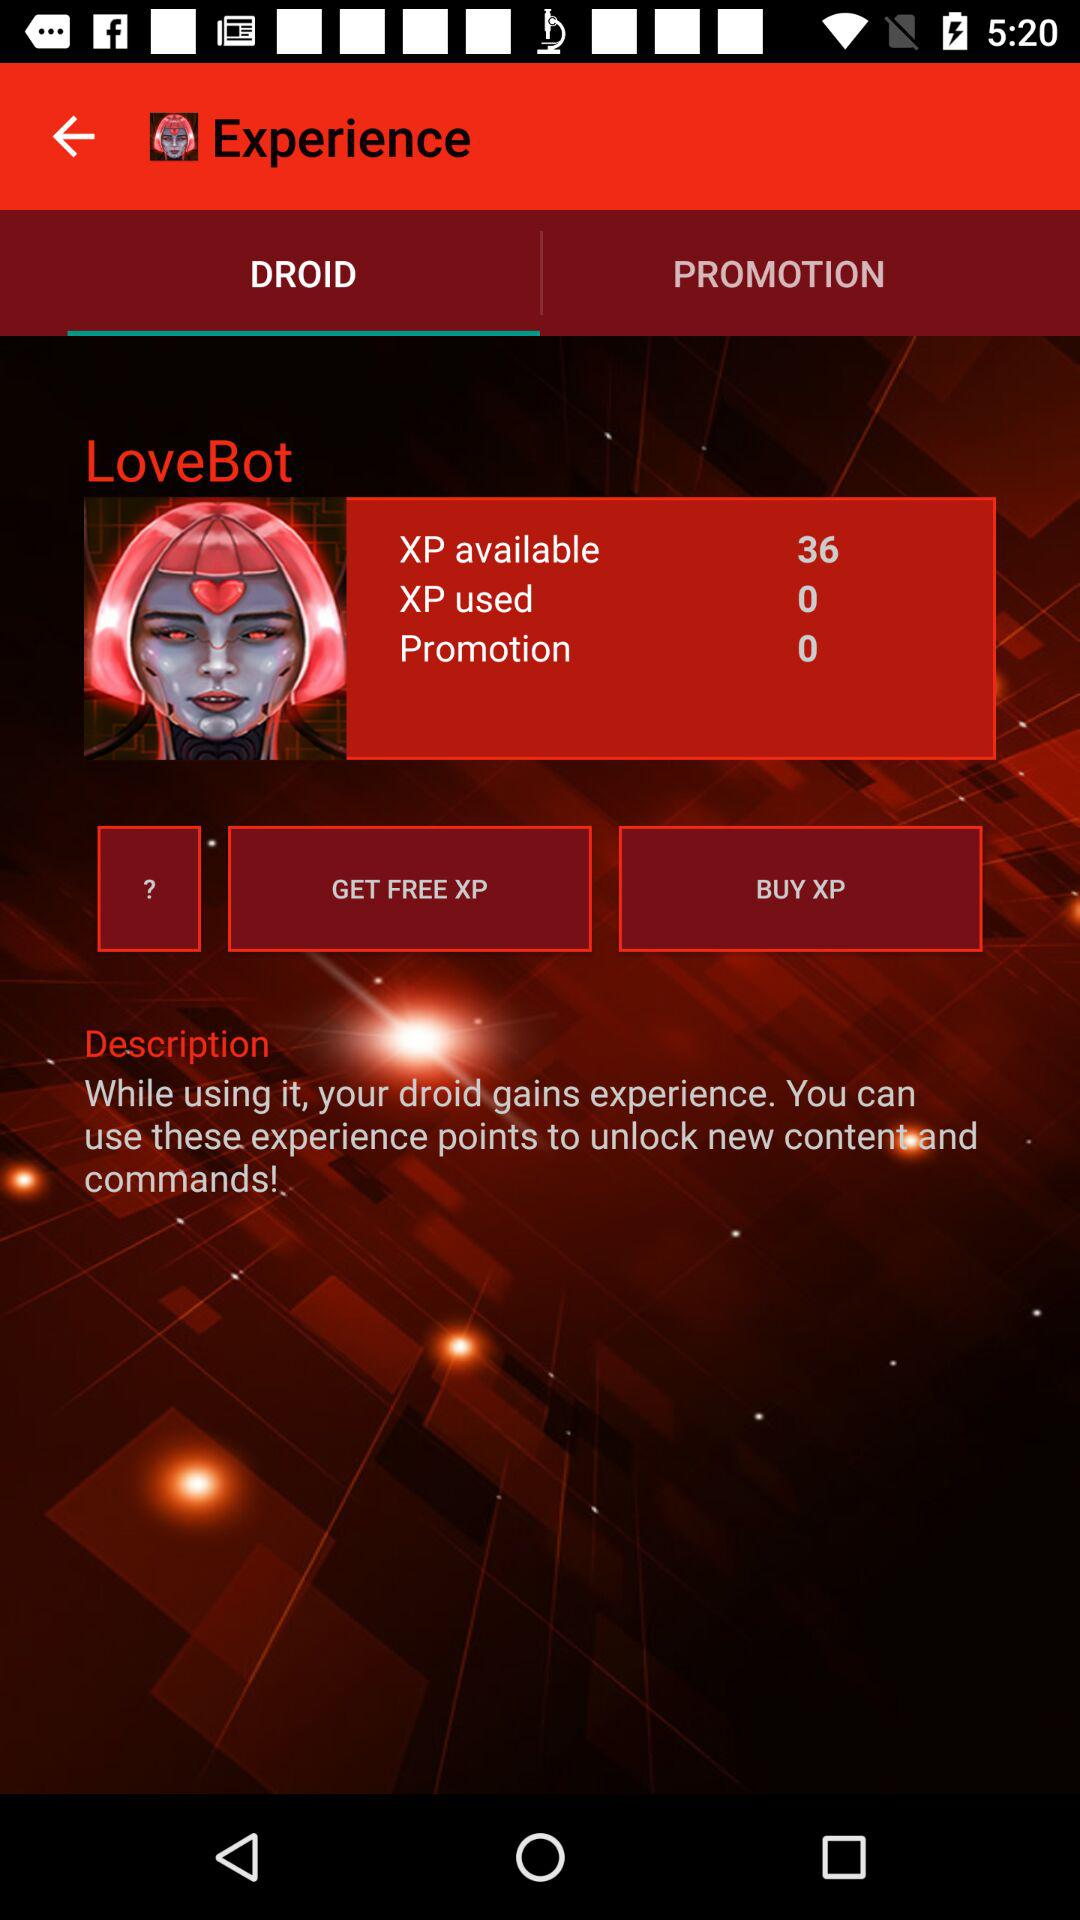How much more XP is available than used?
Answer the question using a single word or phrase. 36 